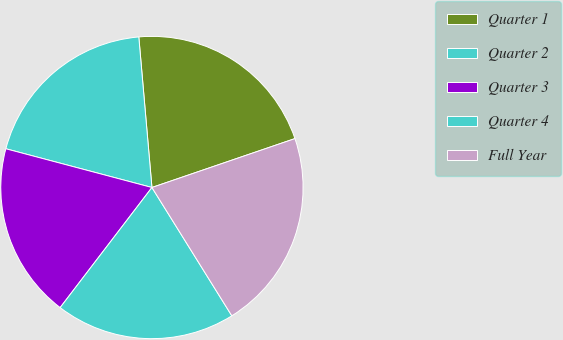Convert chart. <chart><loc_0><loc_0><loc_500><loc_500><pie_chart><fcel>Quarter 1<fcel>Quarter 2<fcel>Quarter 3<fcel>Quarter 4<fcel>Full Year<nl><fcel>21.14%<fcel>19.49%<fcel>18.74%<fcel>19.25%<fcel>21.38%<nl></chart> 